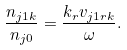Convert formula to latex. <formula><loc_0><loc_0><loc_500><loc_500>\frac { n _ { j 1 k } } { n _ { j 0 } } = \frac { k _ { r } v _ { j 1 r k } } { \omega } .</formula> 